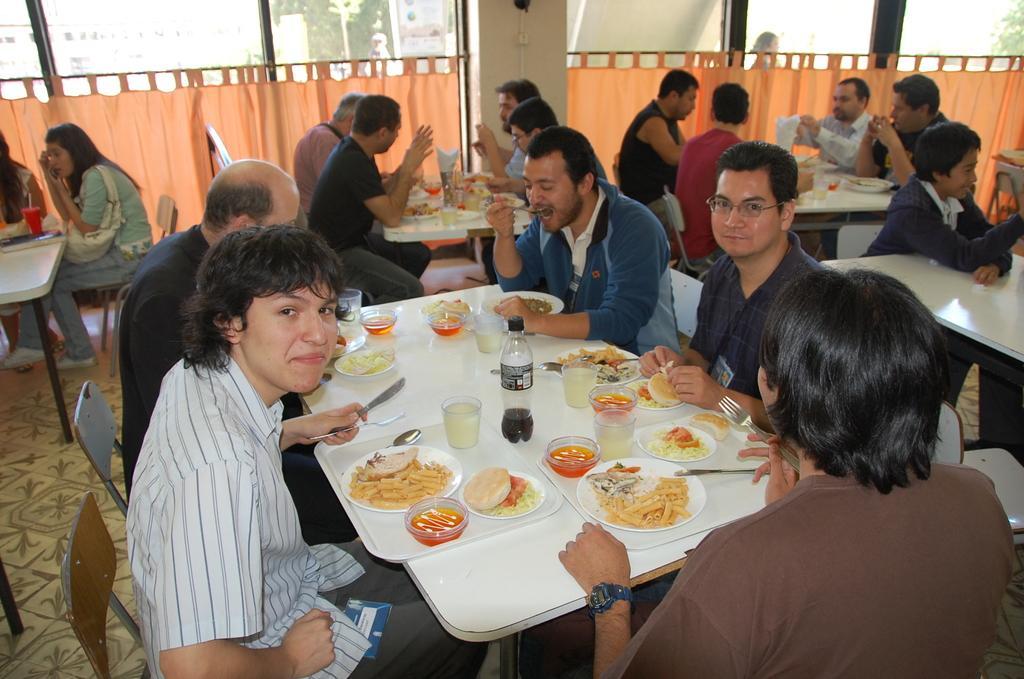In one or two sentences, can you explain what this image depicts? Here we can see that a group of people sitting on the chair, and in front here is the dining table and food items on it and bottles glasses and some objects on it,and here is the curtain, and here is the pillar. 